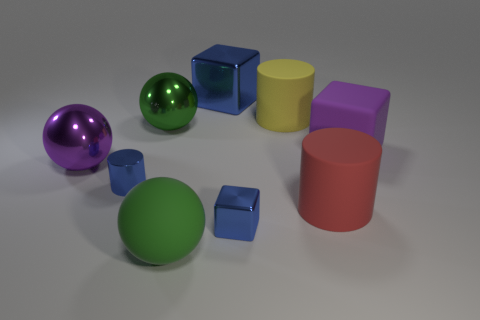Subtract all matte cylinders. How many cylinders are left? 1 Add 1 purple matte objects. How many objects exist? 10 Subtract all purple balls. How many balls are left? 2 Subtract 2 cubes. How many cubes are left? 1 Add 5 large green balls. How many large green balls exist? 7 Subtract 1 green balls. How many objects are left? 8 Subtract all spheres. How many objects are left? 6 Subtract all green cylinders. Subtract all gray balls. How many cylinders are left? 3 Subtract all purple blocks. How many yellow cylinders are left? 1 Subtract all small yellow rubber objects. Subtract all blocks. How many objects are left? 6 